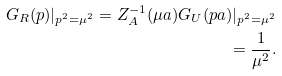<formula> <loc_0><loc_0><loc_500><loc_500>G _ { R } ( p ) | _ { p ^ { 2 } = \mu ^ { 2 } } = Z ^ { - 1 } _ { A } ( \mu a ) G _ { U } ( p a ) | _ { p ^ { 2 } = \mu ^ { 2 } } \\ = \frac { 1 } { \mu ^ { 2 } } .</formula> 